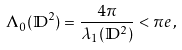Convert formula to latex. <formula><loc_0><loc_0><loc_500><loc_500>\Lambda _ { 0 } ( \mathbb { D } ^ { 2 } ) = \frac { 4 \pi } { \lambda _ { 1 } ( \mathbb { D } ^ { 2 } ) } < \pi e \, ,</formula> 